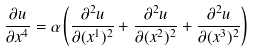Convert formula to latex. <formula><loc_0><loc_0><loc_500><loc_500>\frac { \partial u } { \partial x ^ { 4 } } = \alpha \left ( \frac { \partial ^ { 2 } u } { \partial ( x ^ { 1 } ) ^ { 2 } } + \frac { \partial ^ { 2 } u } { \partial ( x ^ { 2 } ) ^ { 2 } } + \frac { \partial ^ { 2 } u } { \partial ( x ^ { 3 } ) ^ { 2 } } \right )</formula> 